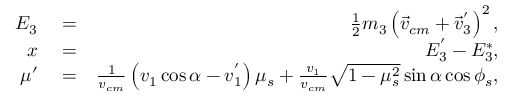Convert formula to latex. <formula><loc_0><loc_0><loc_500><loc_500>\begin{array} { r l r } { E _ { 3 } } & = } & { \frac { 1 } { 2 } m _ { 3 } \left ( \vec { v } _ { c m } + \vec { v } _ { 3 } ^ { ^ { \prime } } \right ) ^ { 2 } , } \\ { x } & = } & { E _ { 3 } ^ { ^ { \prime } } - E _ { 3 } ^ { * } , } \\ { \mu ^ { \prime } } & = } & { \frac { 1 } { v _ { c m } } \left ( v _ { 1 } \cos \alpha - v _ { 1 } ^ { ^ { \prime } } \right ) \mu _ { s } + \frac { v _ { 1 } } { v _ { c m } } \sqrt { 1 - \mu _ { s } ^ { 2 } } \sin \alpha \cos \phi _ { s } , } \end{array}</formula> 